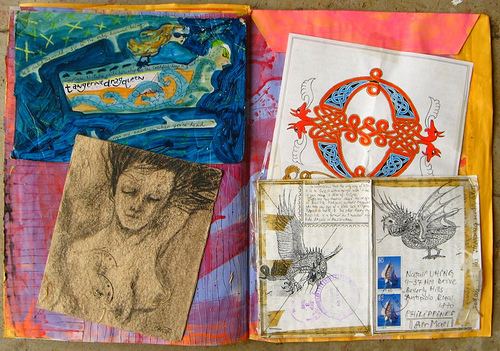<image>
Is the picture to the left of the picture? Yes. From this viewpoint, the picture is positioned to the left side relative to the picture. 